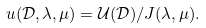Convert formula to latex. <formula><loc_0><loc_0><loc_500><loc_500>u ( \mathcal { D } , \lambda , \mu ) = \mathcal { U } ( \mathcal { D } ) / J ( \lambda , \mu ) .</formula> 